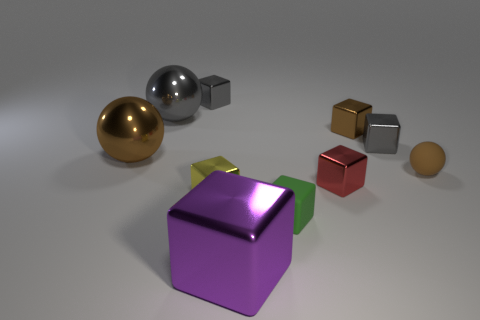Subtract all tiny brown balls. How many balls are left? 2 Subtract all blue blocks. How many brown spheres are left? 2 Subtract all gray blocks. How many blocks are left? 5 Subtract 2 balls. How many balls are left? 1 Subtract all spheres. How many objects are left? 7 Subtract all yellow cubes. Subtract all blue balls. How many cubes are left? 6 Subtract all purple objects. Subtract all yellow metal blocks. How many objects are left? 8 Add 3 purple objects. How many purple objects are left? 4 Add 4 tiny green matte objects. How many tiny green matte objects exist? 5 Subtract 1 gray spheres. How many objects are left? 9 